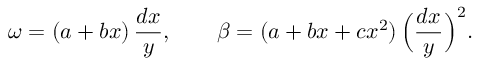Convert formula to latex. <formula><loc_0><loc_0><loc_500><loc_500>\omega = ( a + b x ) \, \frac { d x } { y } , \quad \beta = ( a + b x + c x ^ { 2 } ) \, \left ( \frac { d x } { y } \right ) ^ { 2 } .</formula> 